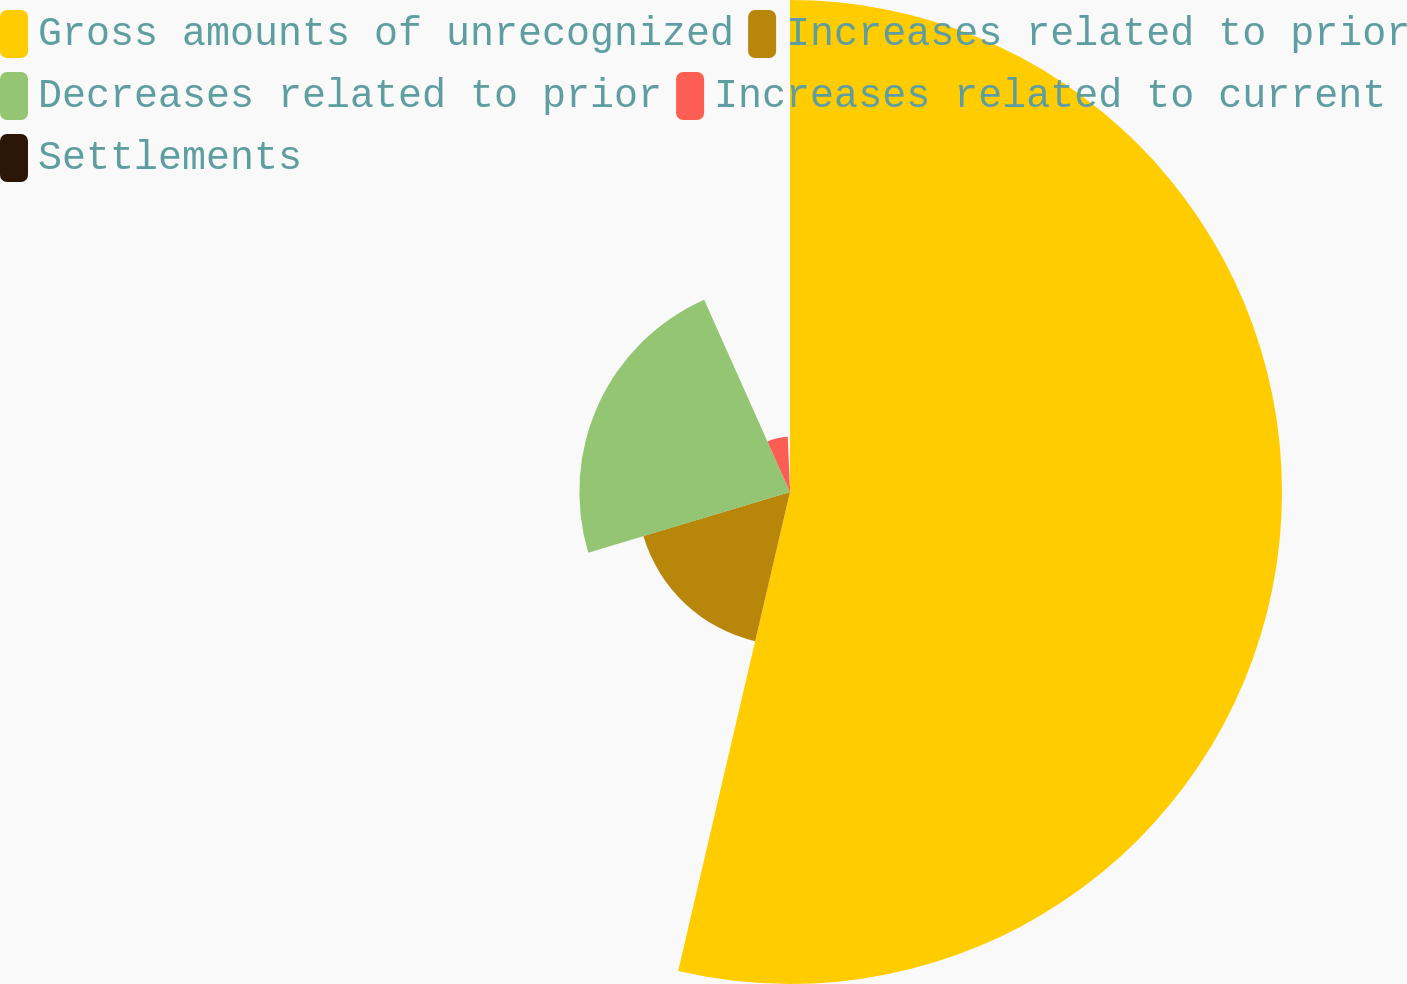<chart> <loc_0><loc_0><loc_500><loc_500><pie_chart><fcel>Gross amounts of unrecognized<fcel>Increases related to prior<fcel>Decreases related to prior<fcel>Increases related to current<fcel>Settlements<nl><fcel>53.65%<fcel>16.7%<fcel>22.97%<fcel>6.04%<fcel>0.64%<nl></chart> 